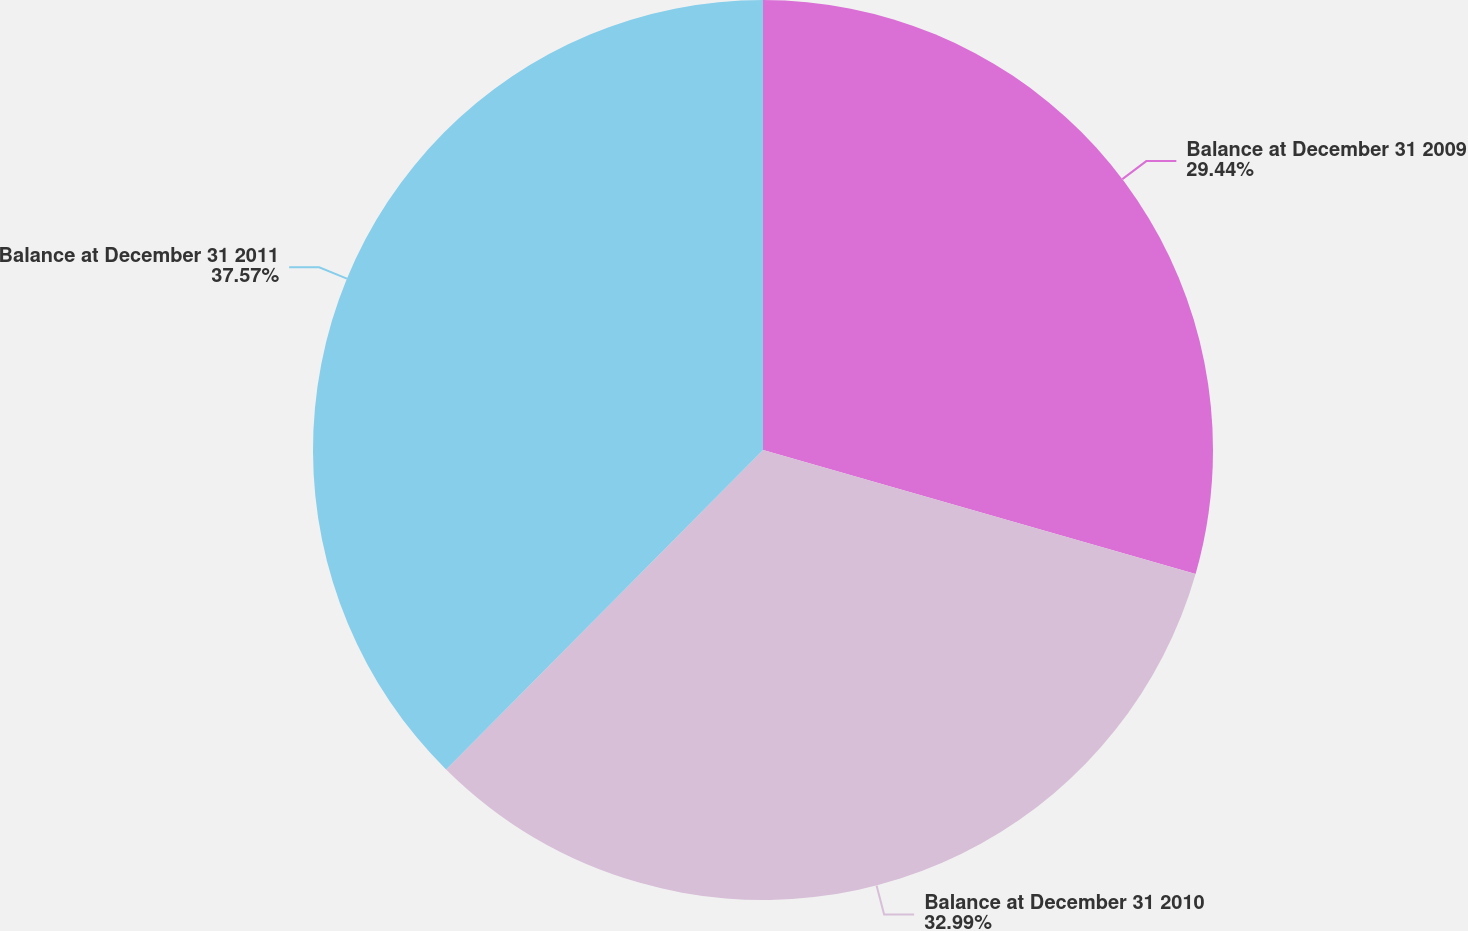Convert chart. <chart><loc_0><loc_0><loc_500><loc_500><pie_chart><fcel>Balance at December 31 2009<fcel>Balance at December 31 2010<fcel>Balance at December 31 2011<nl><fcel>29.44%<fcel>32.99%<fcel>37.56%<nl></chart> 